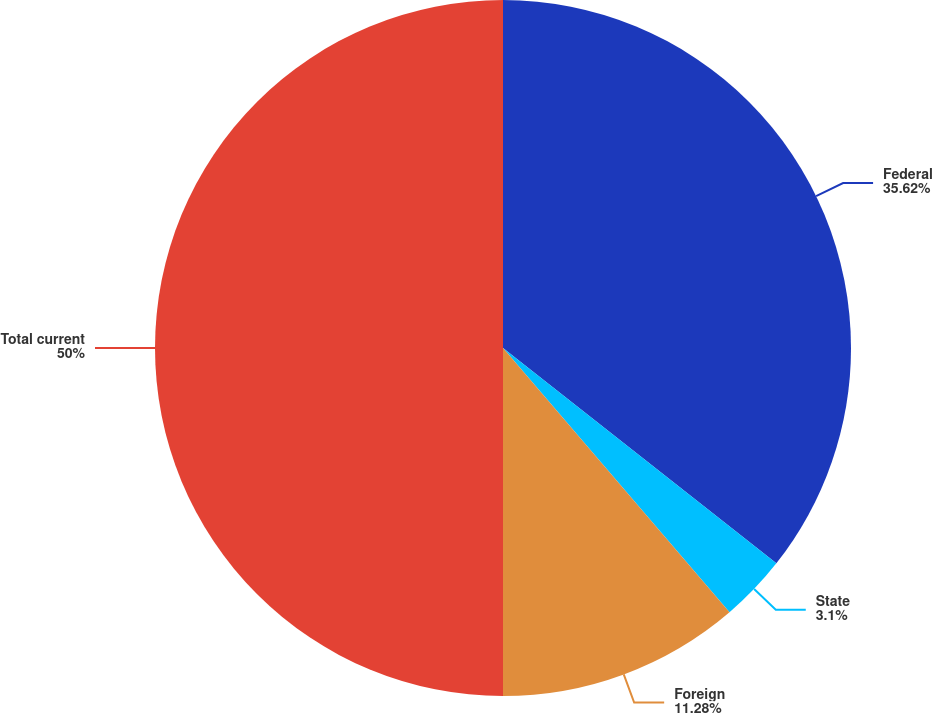Convert chart. <chart><loc_0><loc_0><loc_500><loc_500><pie_chart><fcel>Federal<fcel>State<fcel>Foreign<fcel>Total current<nl><fcel>35.62%<fcel>3.1%<fcel>11.28%<fcel>50.0%<nl></chart> 